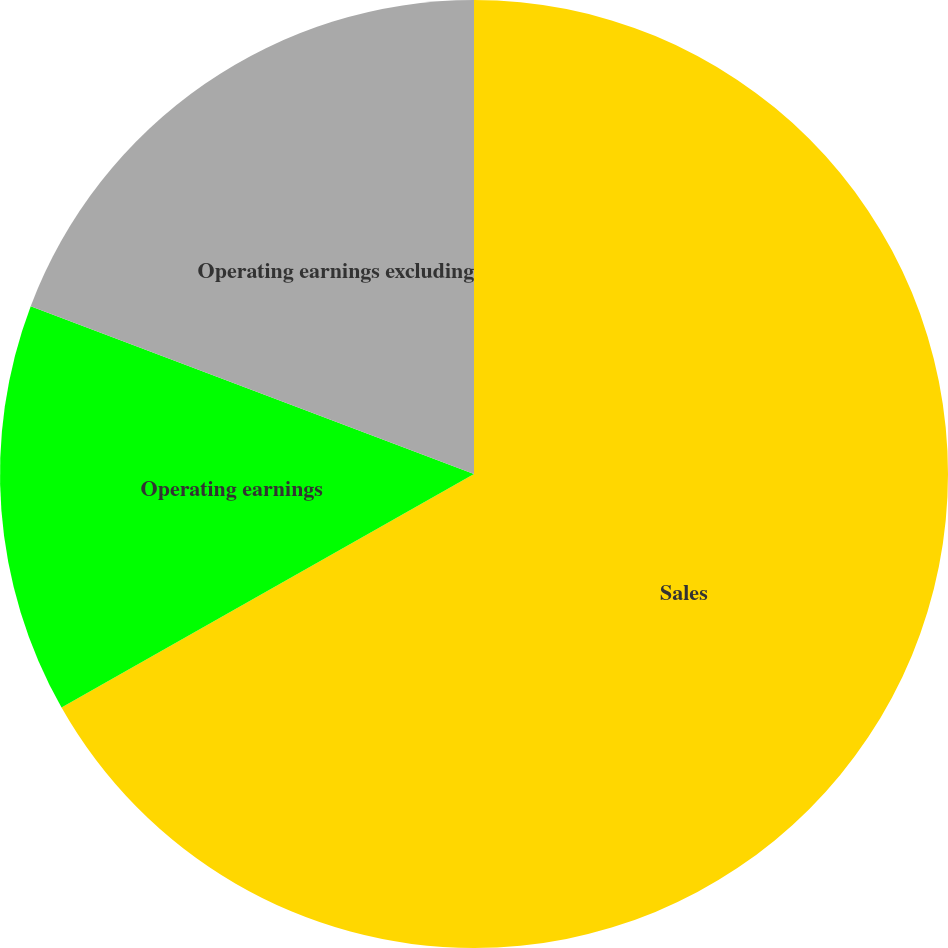Convert chart. <chart><loc_0><loc_0><loc_500><loc_500><pie_chart><fcel>Sales<fcel>Operating earnings<fcel>Operating earnings excluding<nl><fcel>66.8%<fcel>13.96%<fcel>19.24%<nl></chart> 